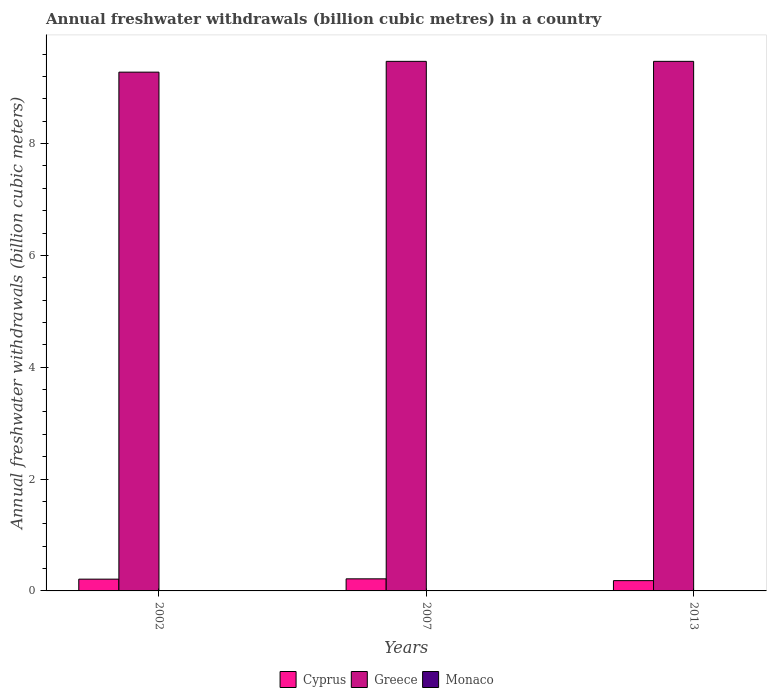How many different coloured bars are there?
Your response must be concise. 3. Are the number of bars per tick equal to the number of legend labels?
Make the answer very short. Yes. How many bars are there on the 2nd tick from the left?
Your response must be concise. 3. How many bars are there on the 1st tick from the right?
Offer a very short reply. 3. What is the annual freshwater withdrawals in Cyprus in 2002?
Your answer should be compact. 0.21. Across all years, what is the maximum annual freshwater withdrawals in Greece?
Give a very brief answer. 9.47. Across all years, what is the minimum annual freshwater withdrawals in Greece?
Ensure brevity in your answer.  9.28. In which year was the annual freshwater withdrawals in Greece maximum?
Offer a very short reply. 2007. What is the total annual freshwater withdrawals in Cyprus in the graph?
Your response must be concise. 0.61. What is the difference between the annual freshwater withdrawals in Cyprus in 2007 and that in 2013?
Your answer should be compact. 0.03. What is the difference between the annual freshwater withdrawals in Monaco in 2002 and the annual freshwater withdrawals in Greece in 2013?
Your answer should be very brief. -9.47. What is the average annual freshwater withdrawals in Greece per year?
Offer a very short reply. 9.41. In the year 2013, what is the difference between the annual freshwater withdrawals in Greece and annual freshwater withdrawals in Cyprus?
Make the answer very short. 9.29. What is the ratio of the annual freshwater withdrawals in Cyprus in 2007 to that in 2013?
Provide a succinct answer. 1.17. What is the difference between the highest and the second highest annual freshwater withdrawals in Greece?
Provide a short and direct response. 0. What is the difference between the highest and the lowest annual freshwater withdrawals in Monaco?
Offer a very short reply. 0. What does the 1st bar from the right in 2002 represents?
Keep it short and to the point. Monaco. How many bars are there?
Your answer should be very brief. 9. Are all the bars in the graph horizontal?
Offer a very short reply. No. What is the difference between two consecutive major ticks on the Y-axis?
Ensure brevity in your answer.  2. Are the values on the major ticks of Y-axis written in scientific E-notation?
Your answer should be very brief. No. How many legend labels are there?
Your answer should be compact. 3. What is the title of the graph?
Ensure brevity in your answer.  Annual freshwater withdrawals (billion cubic metres) in a country. Does "Iraq" appear as one of the legend labels in the graph?
Make the answer very short. No. What is the label or title of the X-axis?
Provide a succinct answer. Years. What is the label or title of the Y-axis?
Make the answer very short. Annual freshwater withdrawals (billion cubic meters). What is the Annual freshwater withdrawals (billion cubic meters) of Cyprus in 2002?
Make the answer very short. 0.21. What is the Annual freshwater withdrawals (billion cubic meters) in Greece in 2002?
Provide a short and direct response. 9.28. What is the Annual freshwater withdrawals (billion cubic meters) in Monaco in 2002?
Offer a very short reply. 0.01. What is the Annual freshwater withdrawals (billion cubic meters) of Cyprus in 2007?
Ensure brevity in your answer.  0.22. What is the Annual freshwater withdrawals (billion cubic meters) of Greece in 2007?
Make the answer very short. 9.47. What is the Annual freshwater withdrawals (billion cubic meters) in Monaco in 2007?
Ensure brevity in your answer.  0.01. What is the Annual freshwater withdrawals (billion cubic meters) in Cyprus in 2013?
Give a very brief answer. 0.18. What is the Annual freshwater withdrawals (billion cubic meters) in Greece in 2013?
Provide a short and direct response. 9.47. What is the Annual freshwater withdrawals (billion cubic meters) in Monaco in 2013?
Your answer should be compact. 0.01. Across all years, what is the maximum Annual freshwater withdrawals (billion cubic meters) of Cyprus?
Give a very brief answer. 0.22. Across all years, what is the maximum Annual freshwater withdrawals (billion cubic meters) in Greece?
Your answer should be very brief. 9.47. Across all years, what is the maximum Annual freshwater withdrawals (billion cubic meters) of Monaco?
Give a very brief answer. 0.01. Across all years, what is the minimum Annual freshwater withdrawals (billion cubic meters) in Cyprus?
Your response must be concise. 0.18. Across all years, what is the minimum Annual freshwater withdrawals (billion cubic meters) in Greece?
Your answer should be very brief. 9.28. Across all years, what is the minimum Annual freshwater withdrawals (billion cubic meters) in Monaco?
Offer a terse response. 0.01. What is the total Annual freshwater withdrawals (billion cubic meters) of Cyprus in the graph?
Give a very brief answer. 0.61. What is the total Annual freshwater withdrawals (billion cubic meters) in Greece in the graph?
Give a very brief answer. 28.22. What is the total Annual freshwater withdrawals (billion cubic meters) of Monaco in the graph?
Provide a short and direct response. 0.02. What is the difference between the Annual freshwater withdrawals (billion cubic meters) in Cyprus in 2002 and that in 2007?
Provide a short and direct response. -0.01. What is the difference between the Annual freshwater withdrawals (billion cubic meters) of Greece in 2002 and that in 2007?
Give a very brief answer. -0.19. What is the difference between the Annual freshwater withdrawals (billion cubic meters) in Monaco in 2002 and that in 2007?
Offer a terse response. 0. What is the difference between the Annual freshwater withdrawals (billion cubic meters) of Cyprus in 2002 and that in 2013?
Your response must be concise. 0.03. What is the difference between the Annual freshwater withdrawals (billion cubic meters) in Greece in 2002 and that in 2013?
Provide a short and direct response. -0.19. What is the difference between the Annual freshwater withdrawals (billion cubic meters) of Monaco in 2002 and that in 2013?
Your response must be concise. 0. What is the difference between the Annual freshwater withdrawals (billion cubic meters) of Cyprus in 2007 and that in 2013?
Make the answer very short. 0.03. What is the difference between the Annual freshwater withdrawals (billion cubic meters) in Greece in 2007 and that in 2013?
Offer a very short reply. 0. What is the difference between the Annual freshwater withdrawals (billion cubic meters) in Cyprus in 2002 and the Annual freshwater withdrawals (billion cubic meters) in Greece in 2007?
Keep it short and to the point. -9.26. What is the difference between the Annual freshwater withdrawals (billion cubic meters) in Cyprus in 2002 and the Annual freshwater withdrawals (billion cubic meters) in Monaco in 2007?
Your answer should be very brief. 0.2. What is the difference between the Annual freshwater withdrawals (billion cubic meters) in Greece in 2002 and the Annual freshwater withdrawals (billion cubic meters) in Monaco in 2007?
Make the answer very short. 9.27. What is the difference between the Annual freshwater withdrawals (billion cubic meters) of Cyprus in 2002 and the Annual freshwater withdrawals (billion cubic meters) of Greece in 2013?
Keep it short and to the point. -9.26. What is the difference between the Annual freshwater withdrawals (billion cubic meters) in Cyprus in 2002 and the Annual freshwater withdrawals (billion cubic meters) in Monaco in 2013?
Keep it short and to the point. 0.21. What is the difference between the Annual freshwater withdrawals (billion cubic meters) in Greece in 2002 and the Annual freshwater withdrawals (billion cubic meters) in Monaco in 2013?
Your answer should be very brief. 9.27. What is the difference between the Annual freshwater withdrawals (billion cubic meters) of Cyprus in 2007 and the Annual freshwater withdrawals (billion cubic meters) of Greece in 2013?
Keep it short and to the point. -9.26. What is the difference between the Annual freshwater withdrawals (billion cubic meters) in Cyprus in 2007 and the Annual freshwater withdrawals (billion cubic meters) in Monaco in 2013?
Your answer should be very brief. 0.21. What is the difference between the Annual freshwater withdrawals (billion cubic meters) in Greece in 2007 and the Annual freshwater withdrawals (billion cubic meters) in Monaco in 2013?
Make the answer very short. 9.47. What is the average Annual freshwater withdrawals (billion cubic meters) in Cyprus per year?
Your response must be concise. 0.2. What is the average Annual freshwater withdrawals (billion cubic meters) of Greece per year?
Offer a terse response. 9.41. What is the average Annual freshwater withdrawals (billion cubic meters) in Monaco per year?
Give a very brief answer. 0.01. In the year 2002, what is the difference between the Annual freshwater withdrawals (billion cubic meters) of Cyprus and Annual freshwater withdrawals (billion cubic meters) of Greece?
Your response must be concise. -9.07. In the year 2002, what is the difference between the Annual freshwater withdrawals (billion cubic meters) in Cyprus and Annual freshwater withdrawals (billion cubic meters) in Monaco?
Keep it short and to the point. 0.2. In the year 2002, what is the difference between the Annual freshwater withdrawals (billion cubic meters) of Greece and Annual freshwater withdrawals (billion cubic meters) of Monaco?
Your answer should be very brief. 9.27. In the year 2007, what is the difference between the Annual freshwater withdrawals (billion cubic meters) in Cyprus and Annual freshwater withdrawals (billion cubic meters) in Greece?
Your answer should be compact. -9.26. In the year 2007, what is the difference between the Annual freshwater withdrawals (billion cubic meters) of Cyprus and Annual freshwater withdrawals (billion cubic meters) of Monaco?
Offer a terse response. 0.21. In the year 2007, what is the difference between the Annual freshwater withdrawals (billion cubic meters) of Greece and Annual freshwater withdrawals (billion cubic meters) of Monaco?
Give a very brief answer. 9.47. In the year 2013, what is the difference between the Annual freshwater withdrawals (billion cubic meters) in Cyprus and Annual freshwater withdrawals (billion cubic meters) in Greece?
Provide a succinct answer. -9.29. In the year 2013, what is the difference between the Annual freshwater withdrawals (billion cubic meters) of Cyprus and Annual freshwater withdrawals (billion cubic meters) of Monaco?
Give a very brief answer. 0.18. In the year 2013, what is the difference between the Annual freshwater withdrawals (billion cubic meters) in Greece and Annual freshwater withdrawals (billion cubic meters) in Monaco?
Give a very brief answer. 9.47. What is the ratio of the Annual freshwater withdrawals (billion cubic meters) in Cyprus in 2002 to that in 2007?
Make the answer very short. 0.97. What is the ratio of the Annual freshwater withdrawals (billion cubic meters) of Greece in 2002 to that in 2007?
Your response must be concise. 0.98. What is the ratio of the Annual freshwater withdrawals (billion cubic meters) in Monaco in 2002 to that in 2007?
Make the answer very short. 1.05. What is the ratio of the Annual freshwater withdrawals (billion cubic meters) of Cyprus in 2002 to that in 2013?
Make the answer very short. 1.14. What is the ratio of the Annual freshwater withdrawals (billion cubic meters) of Greece in 2002 to that in 2013?
Offer a terse response. 0.98. What is the ratio of the Annual freshwater withdrawals (billion cubic meters) in Monaco in 2002 to that in 2013?
Give a very brief answer. 1.16. What is the ratio of the Annual freshwater withdrawals (billion cubic meters) of Cyprus in 2007 to that in 2013?
Keep it short and to the point. 1.17. What is the ratio of the Annual freshwater withdrawals (billion cubic meters) in Greece in 2007 to that in 2013?
Offer a terse response. 1. What is the difference between the highest and the second highest Annual freshwater withdrawals (billion cubic meters) in Cyprus?
Offer a terse response. 0.01. What is the difference between the highest and the second highest Annual freshwater withdrawals (billion cubic meters) of Greece?
Give a very brief answer. 0. What is the difference between the highest and the second highest Annual freshwater withdrawals (billion cubic meters) of Monaco?
Offer a very short reply. 0. What is the difference between the highest and the lowest Annual freshwater withdrawals (billion cubic meters) in Cyprus?
Your response must be concise. 0.03. What is the difference between the highest and the lowest Annual freshwater withdrawals (billion cubic meters) in Greece?
Make the answer very short. 0.19. What is the difference between the highest and the lowest Annual freshwater withdrawals (billion cubic meters) of Monaco?
Your answer should be compact. 0. 